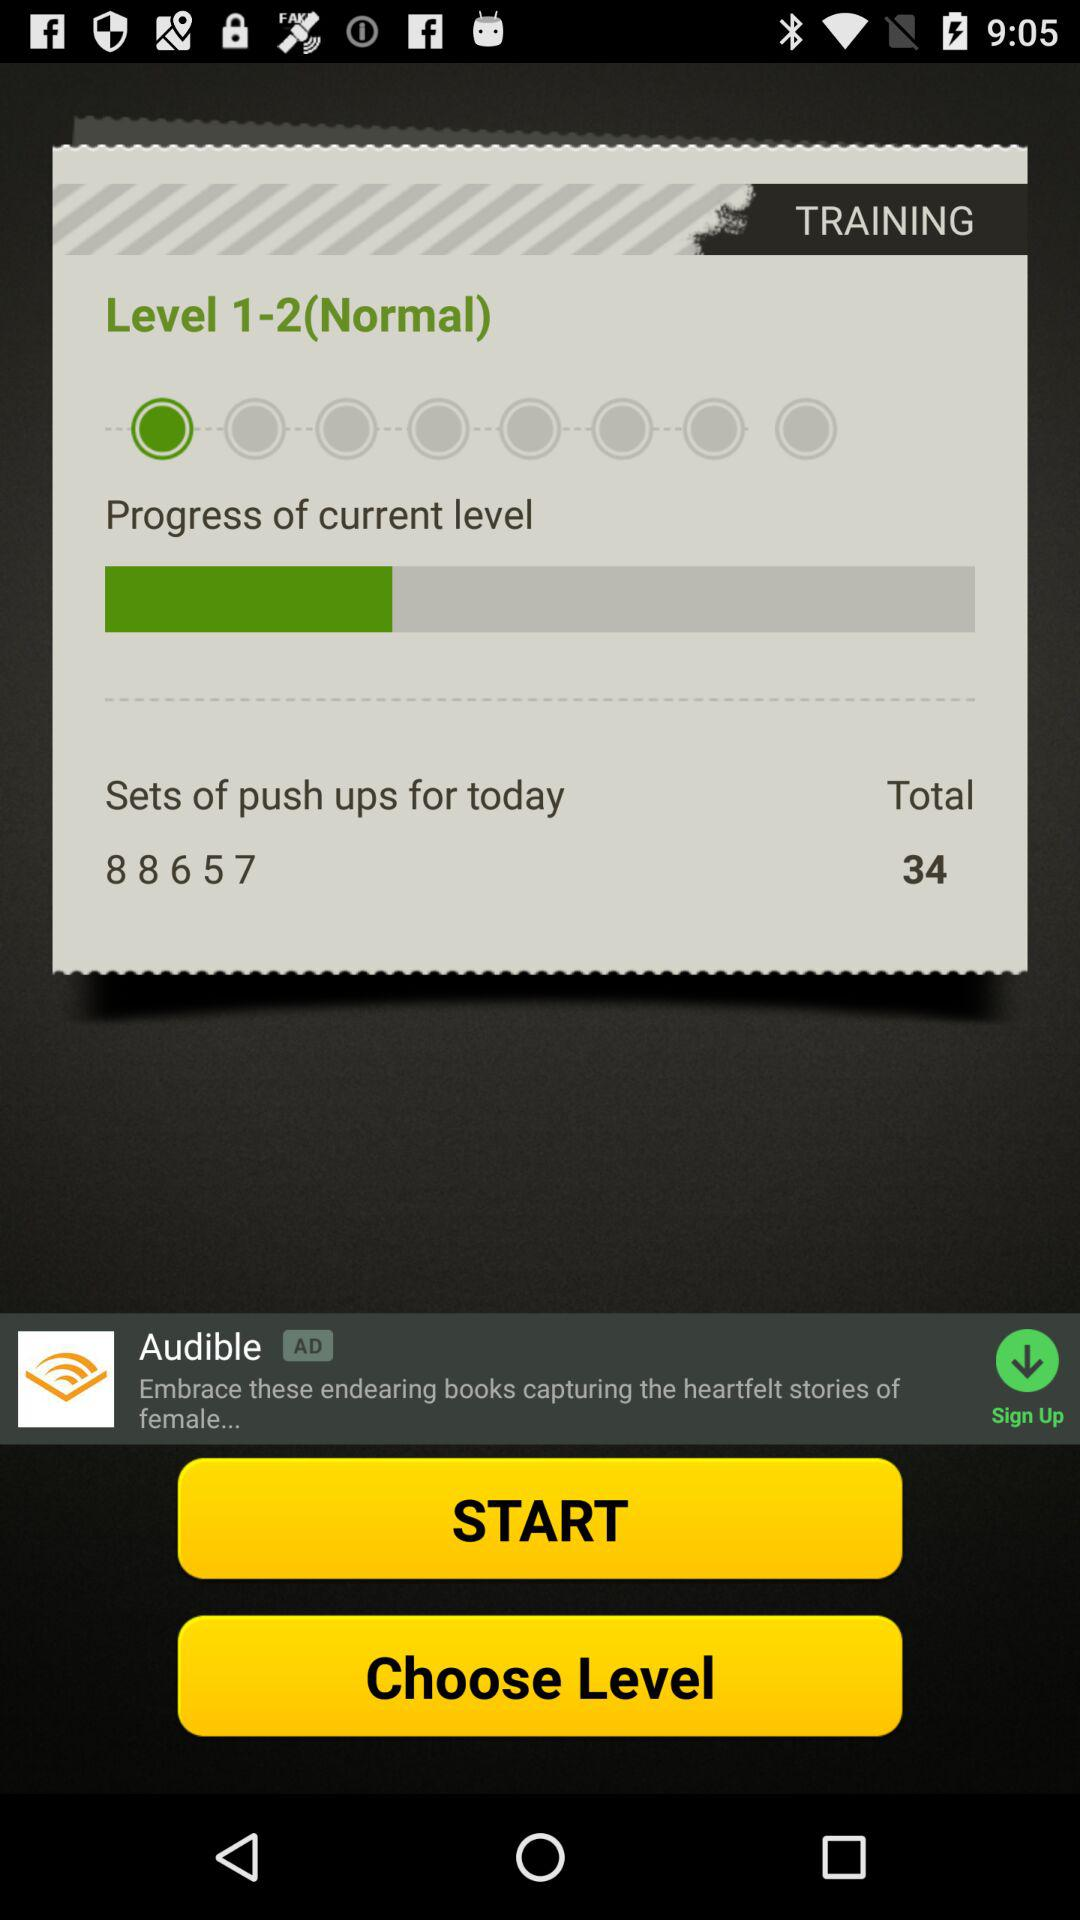How many pushups are to be performed today? There are 34 pushups to be performed today. 